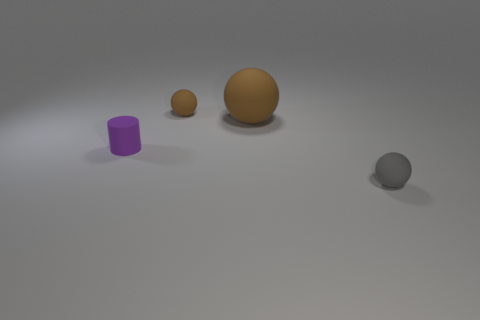Subtract all small balls. How many balls are left? 1 Subtract all gray balls. How many balls are left? 2 Subtract 1 cylinders. How many cylinders are left? 0 Subtract all blue blocks. How many gray spheres are left? 1 Subtract all gray rubber spheres. Subtract all big gray shiny objects. How many objects are left? 3 Add 4 large objects. How many large objects are left? 5 Add 2 matte spheres. How many matte spheres exist? 5 Add 3 purple rubber things. How many objects exist? 7 Subtract 1 gray balls. How many objects are left? 3 Subtract all spheres. How many objects are left? 1 